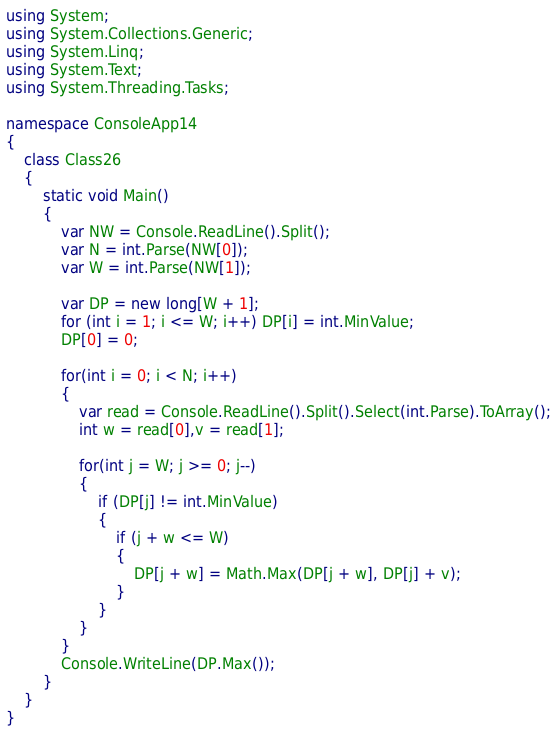<code> <loc_0><loc_0><loc_500><loc_500><_C#_>using System;
using System.Collections.Generic;
using System.Linq;
using System.Text;
using System.Threading.Tasks;

namespace ConsoleApp14
{
    class Class26
    {
        static void Main()
        {
            var NW = Console.ReadLine().Split();
            var N = int.Parse(NW[0]);
            var W = int.Parse(NW[1]);

            var DP = new long[W + 1];
            for (int i = 1; i <= W; i++) DP[i] = int.MinValue;
            DP[0] = 0;

            for(int i = 0; i < N; i++)
            {
                var read = Console.ReadLine().Split().Select(int.Parse).ToArray();
                int w = read[0],v = read[1];

                for(int j = W; j >= 0; j--)
                {
                    if (DP[j] != int.MinValue)
                    {
                        if (j + w <= W)
                        {
                            DP[j + w] = Math.Max(DP[j + w], DP[j] + v);
                        }
                    }
                }
            }
            Console.WriteLine(DP.Max());
        }
    }
}
</code> 